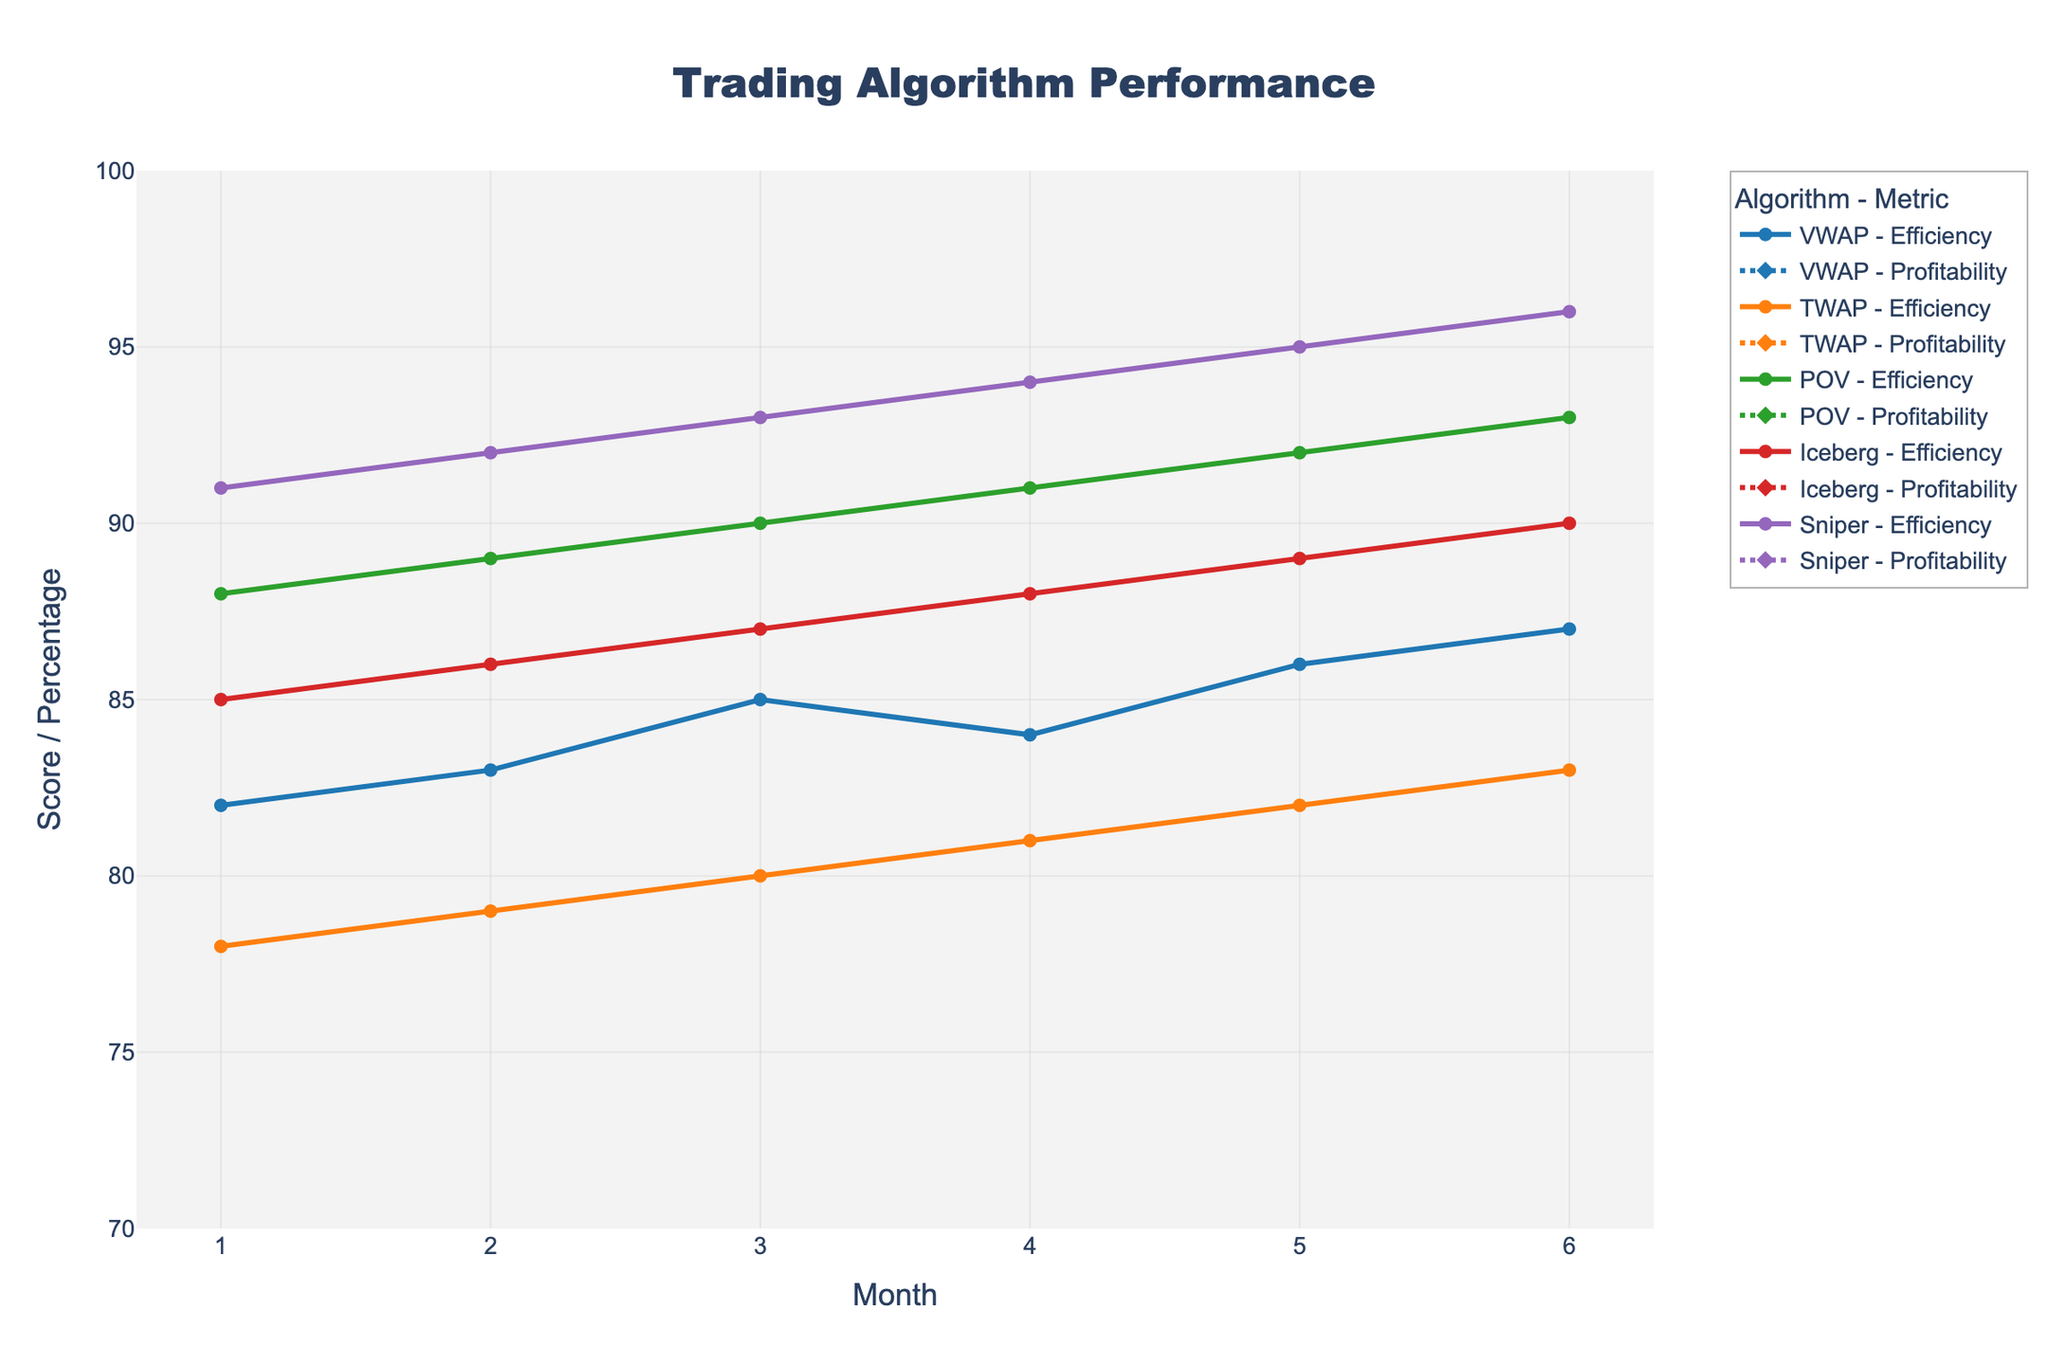What's the highest Efficiency Score for the Sniper algorithm? To find this, look for the maximum Efficiency Score associated with the Sniper algorithm. From the figure, the Sniper algorithm always outperforms others in Efficiency Score, peaking at 96 in month 6.
Answer: 96 Which algorithm had the highest Profitability Percentage in month 3? To answer this, compare the Profitability Percentages of all algorithms for month 3 in the chart. The Sniper algorithm has the highest value at 3.4%.
Answer: Sniper Between months 4 and 5, which algorithm showed the highest increase in Efficiency Score? Calculate the difference in Efficiency Scores for each algorithm between months 4 and 5. The Sniper algorithm increased from 94 to 95, which is the highest increase of 1 point.
Answer: Sniper What is the average Profibility Percentage of the Iceberg algorithm over 6 months? Sum the Profitability Percentage values for Iceberg (2.4, 2.5, 2.6, 2.7, 2.8, 2.9), and divide by 6. The calculation is (2.4 + 2.5 + 2.6 + 2.7 + 2.8 + 2.9) / 6 = 2.65.
Answer: 2.65 Which algorithm has both higher Efficiency Score and Profitability Percentage than the VWAP algorithm in month 2? Compare both the Efficiency Scores and Profitability Percentages of each algorithm with VWAP's scores in month 2 (Efficiency: 83, Profitability: 2.3). The Sniper algorithm (Efficiency: 92, Profitability: 3.3) and POV (Efficiency: 89, Profitability: 2.9) meet these criteria.
Answer: Sniper and POV Which algorithm performs best in both categories in month 6? Look for the highest Efficiency Score and highest Profitability Percentage in month 6. The Sniper algorithm scores the highest in both categories with Efficiency Score of 96 and Profitability Percentage of 3.7.
Answer: Sniper What's the difference in Profitability Percentage between the VWAP and TWAP algorithms in month 5? Subtract the Profitability Percentage of TWAP from VWAP in month 5. The values are VWAP: 2.6% and TWAP: 2.2%. The difference is 2.6 - 2.2 = 0.4%.
Answer: 0.4% Which algorithm had the least variation in Efficiency Score over the 6 months? To find the algorithm with the least variation, observe the range of Efficiency Scores for each algorithm over the 6 months. The TWAP algorithm's scores range from 78 to 83, showing the least variation of 5 points.
Answer: TWAP 